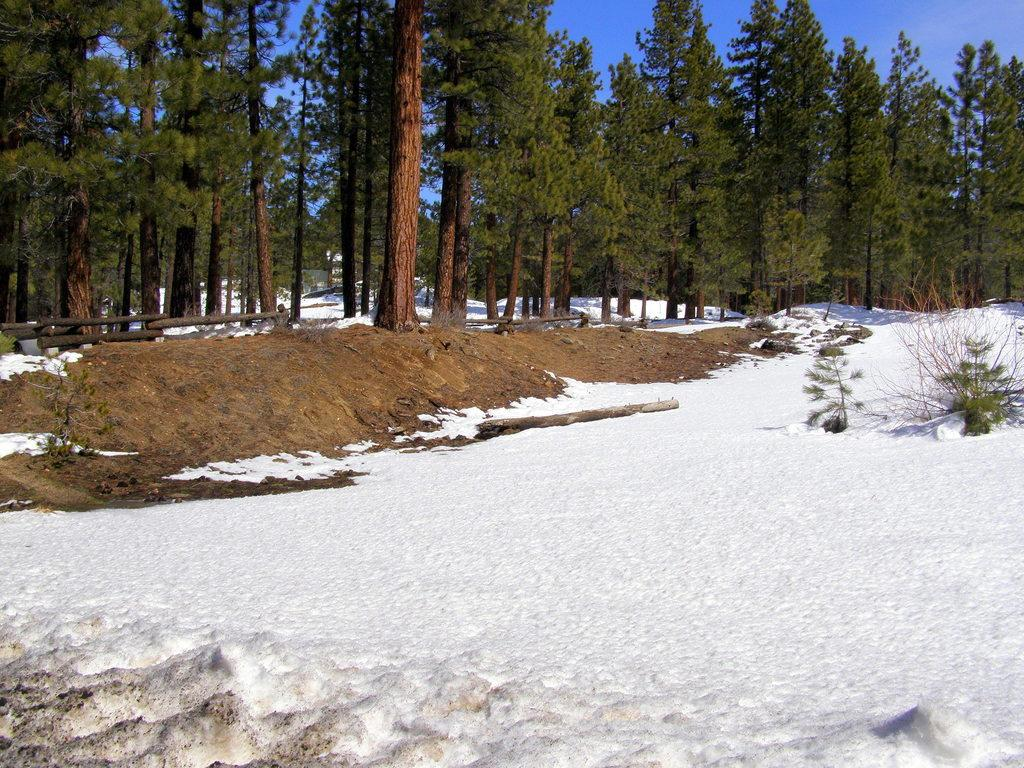What types of natural elements are present at the bottom of the image? There is snow and sand at the bottom of the image. What can be seen in the background of the image? There are trees in the background of the image. What other natural elements are visible in the image? There are plants visible in the image. What is visible at the top of the image? The sky is visible at the top of the image. What type of baseball equipment can be seen in the image? There is no baseball equipment present in the image. Whose birthday is being celebrated in the image? There is no indication of a birthday celebration in the image. 